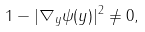<formula> <loc_0><loc_0><loc_500><loc_500>1 - | \nabla _ { y } \psi ( y ) | ^ { 2 } \ne 0 ,</formula> 